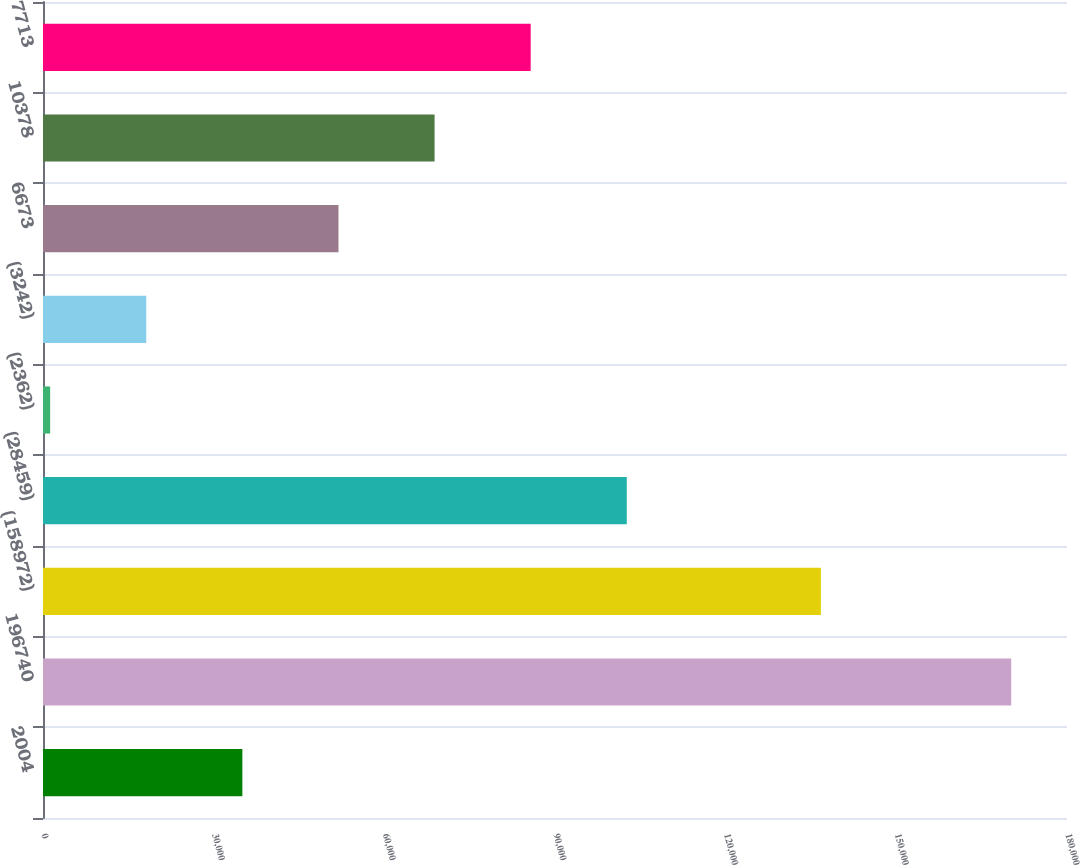Convert chart to OTSL. <chart><loc_0><loc_0><loc_500><loc_500><bar_chart><fcel>2004<fcel>196740<fcel>(158972)<fcel>(28459)<fcel>(2362)<fcel>(3242)<fcel>6673<fcel>10378<fcel>7713<nl><fcel>35044.6<fcel>170195<fcel>136745<fcel>102620<fcel>1257<fcel>18150.8<fcel>51938.4<fcel>68832.2<fcel>85726<nl></chart> 